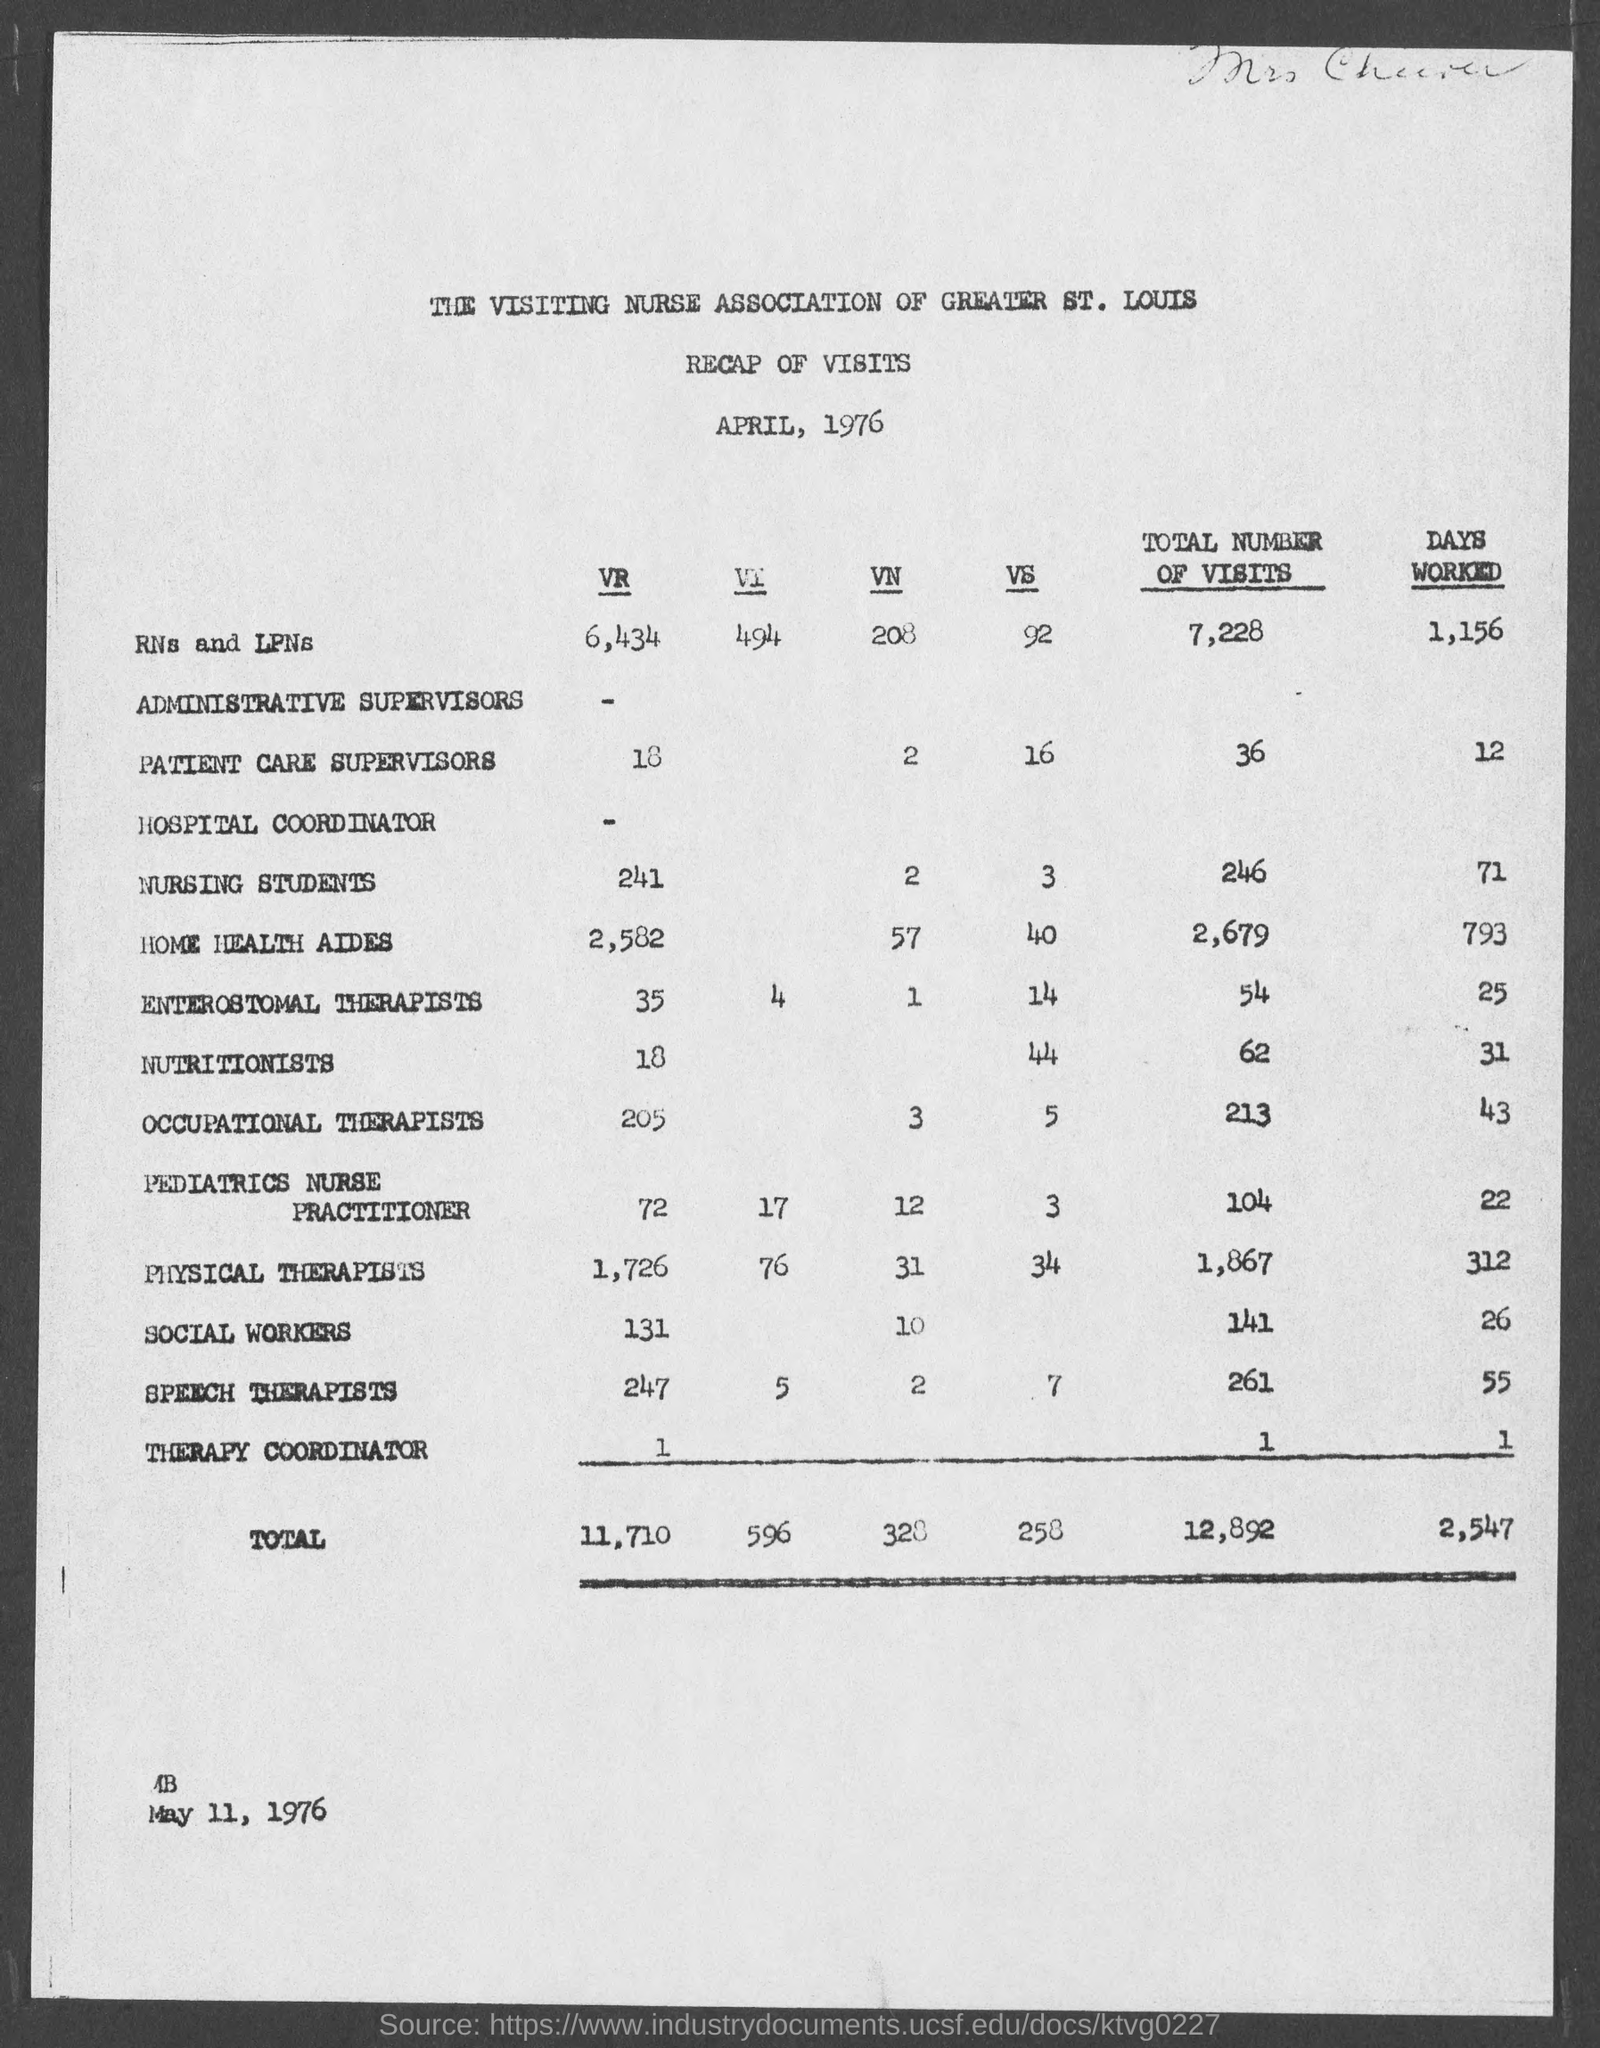What is the total number of visits of nursing students given in the document?
Provide a succinct answer. 246. What is the number of days worked by nutritionists as per the document?
Give a very brief answer. 31. What is the number of days worked by occupational therapists as per the document?
Provide a succinct answer. 43. What is the total number of visits of speech therapists given in the document?
Offer a terse response. 261. What is the number of days worked by RNs and LPNs as per the document?
Your answer should be compact. 1,156. 